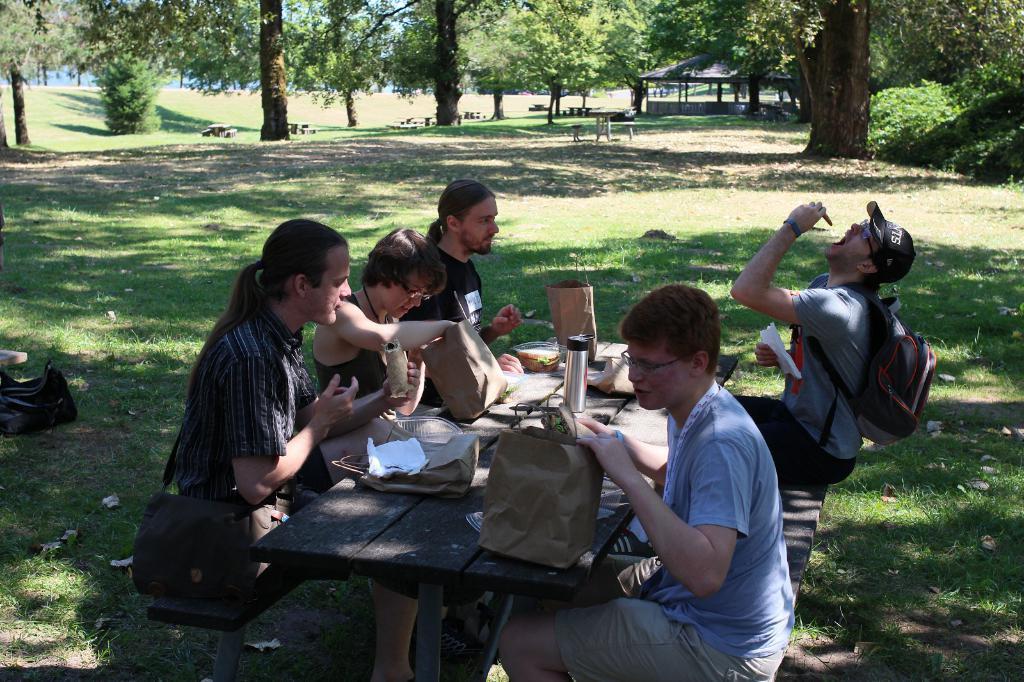Please provide a concise description of this image. In the right side 2 men are sitting on the bench. In the left side a woman is sitting in the middle of this bench. It is a dining table there are green color trees in the long back side of an image. 